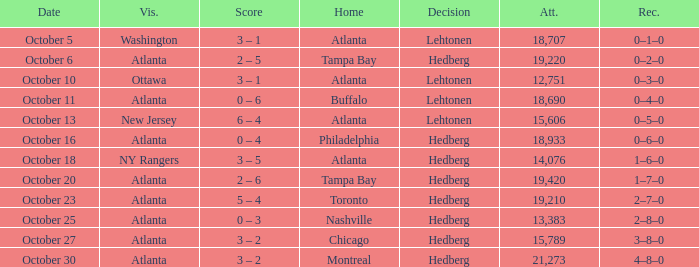What was the record on the game that was played on october 27? 3–8–0. 